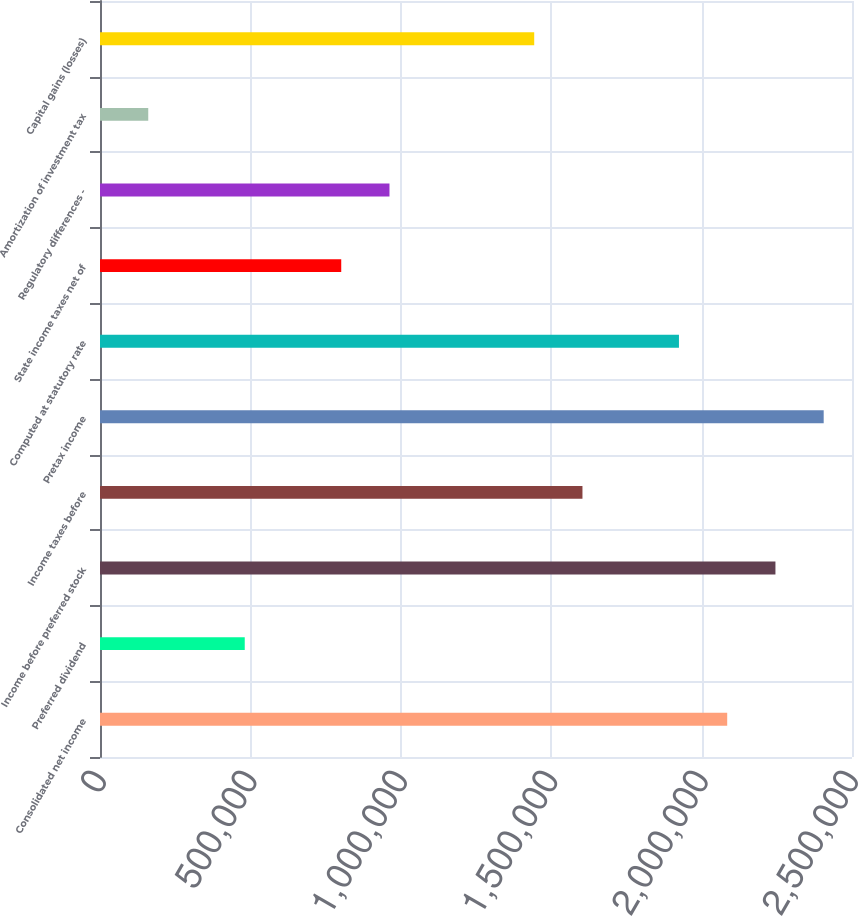Convert chart. <chart><loc_0><loc_0><loc_500><loc_500><bar_chart><fcel>Consolidated net income<fcel>Preferred dividend<fcel>Income before preferred stock<fcel>Income taxes before<fcel>Pretax income<fcel>Computed at statutory rate<fcel>State income taxes net of<fcel>Regulatory differences -<fcel>Amortization of investment tax<fcel>Capital gains (losses)<nl><fcel>2.08509e+06<fcel>481197<fcel>2.24548e+06<fcel>1.60392e+06<fcel>2.40587e+06<fcel>1.9247e+06<fcel>801976<fcel>962366<fcel>160417<fcel>1.44354e+06<nl></chart> 